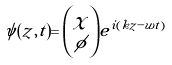Convert formula to latex. <formula><loc_0><loc_0><loc_500><loc_500>\psi ( z , t ) = { \chi \choose \phi } e ^ { i ( k z - w t ) } \,</formula> 